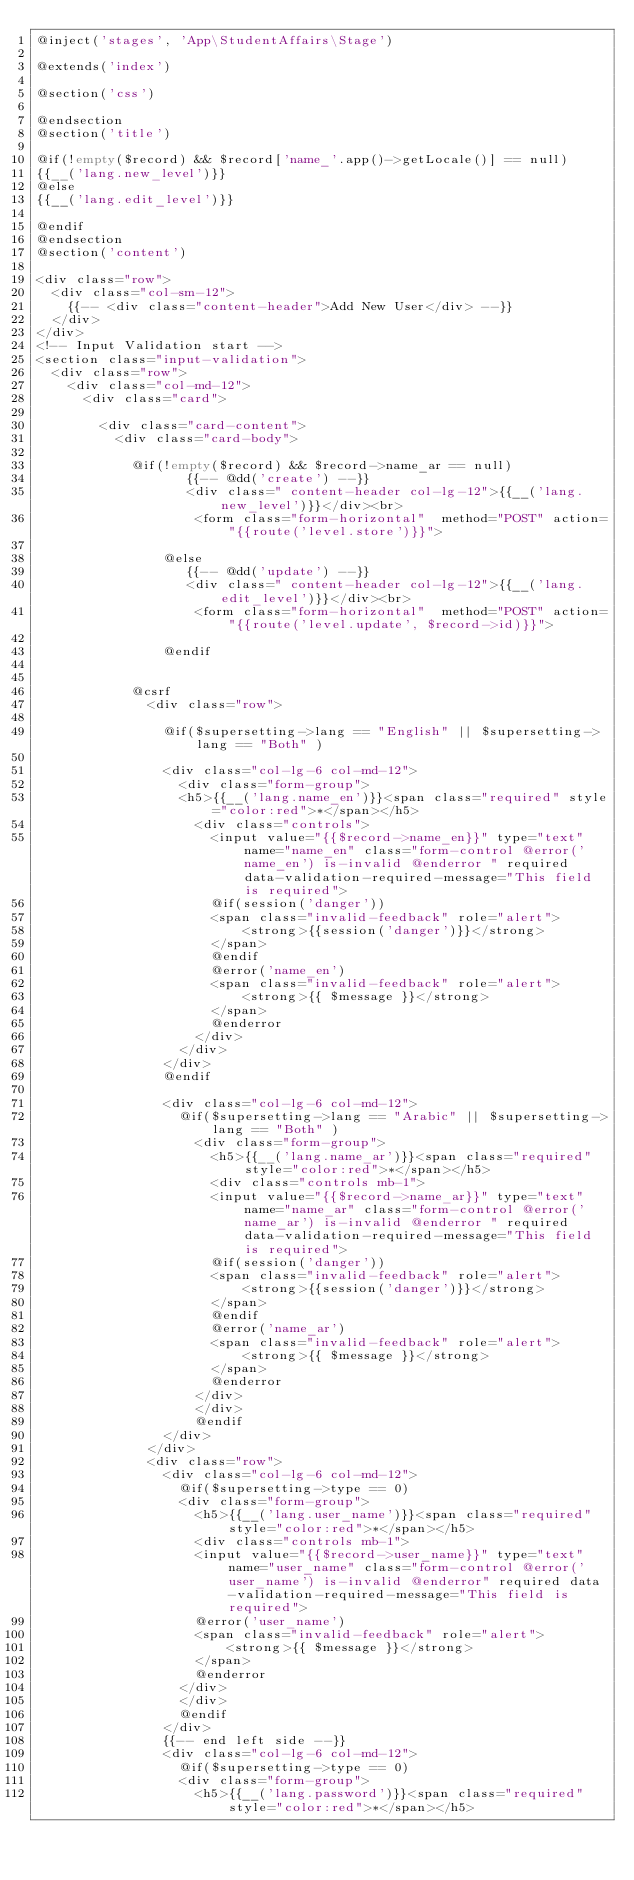Convert code to text. <code><loc_0><loc_0><loc_500><loc_500><_PHP_>@inject('stages', 'App\StudentAffairs\Stage')

@extends('index')

@section('css')

@endsection
@section('title')

@if(!empty($record) && $record['name_'.app()->getLocale()] == null)
{{__('lang.new_level')}}
@else
{{__('lang.edit_level')}}

@endif
@endsection
@section('content')

<div class="row">
  <div class="col-sm-12">
    {{-- <div class="content-header">Add New User</div> --}}
  </div>
</div>
<!-- Input Validation start -->
<section class="input-validation">
  <div class="row">
    <div class="col-md-12">
      <div class="card">
      
        <div class="card-content">
          <div class="card-body">

            @if(!empty($record) && $record->name_ar == null)
                   {{-- @dd('create') --}}
                   <div class=" content-header col-lg-12">{{__('lang.new_level')}}</div><br>
                    <form class="form-horizontal"  method="POST" action="{{route('level.store')}}">

                @else
                   {{-- @dd('update') --}}
                   <div class=" content-header col-lg-12">{{__('lang.edit_level')}}</div><br>
                    <form class="form-horizontal"  method="POST" action="{{route('level.update', $record->id)}}">

                @endif


            @csrf
              <div class="row">

                @if($supersetting->lang == "English" || $supersetting->lang == "Both" )
              
                <div class="col-lg-6 col-md-12">
                  <div class="form-group">
                  <h5>{{__('lang.name_en')}}<span class="required" style="color:red">*</span></h5>
                    <div class="controls">
                      <input value="{{$record->name_en}}" type="text" name="name_en" class="form-control @error('name_en') is-invalid @enderror " required data-validation-required-message="This field is required">
                      @if(session('danger'))
                      <span class="invalid-feedback" role="alert">
                          <strong>{{session('danger')}}</strong>
                      </span>
                      @endif
                      @error('name_en')
                      <span class="invalid-feedback" role="alert">
                          <strong>{{ $message }}</strong>
                      </span>
                      @enderror
                    </div>
                  </div>
                </div>
                @endif

                <div class="col-lg-6 col-md-12">
                  @if($supersetting->lang == "Arabic" || $supersetting->lang == "Both" )
                    <div class="form-group">
                      <h5>{{__('lang.name_ar')}}<span class="required" style="color:red">*</span></h5>
                      <div class="controls mb-1">
                      <input value="{{$record->name_ar}}" type="text" name="name_ar" class="form-control @error('name_ar') is-invalid @enderror " required data-validation-required-message="This field is required">
                      @if(session('danger'))
                      <span class="invalid-feedback" role="alert">
                          <strong>{{session('danger')}}</strong>
                      </span>
                      @endif
                      @error('name_ar')
                      <span class="invalid-feedback" role="alert">
                          <strong>{{ $message }}</strong>
                      </span>
                      @enderror
                    </div>
                    </div>
                    @endif
                </div>
              </div>
              <div class="row">
                <div class="col-lg-6 col-md-12">     
                  @if($supersetting->type == 0)
                  <div class="form-group">
                    <h5>{{__('lang.user_name')}}<span class="required" style="color:red">*</span></h5>
                    <div class="controls mb-1">
                    <input value="{{$record->user_name}}" type="text" name="user_name" class="form-control @error('user_name') is-invalid @enderror" required data-validation-required-message="This field is required">
                    @error('user_name')
                    <span class="invalid-feedback" role="alert">
                        <strong>{{ $message }}</strong>
                    </span>
                    @enderror
                  </div>
                  </div>
                  @endif
                </div>
                {{-- end left side --}}
                <div class="col-lg-6 col-md-12">
                  @if($supersetting->type == 0)
                  <div class="form-group">
                    <h5>{{__('lang.password')}}<span class="required" style="color:red">*</span></h5></code> 